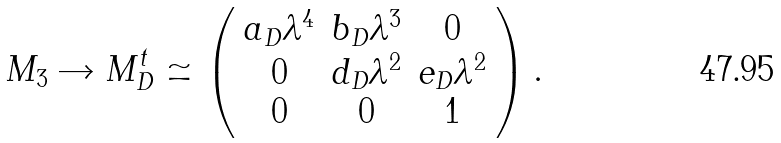Convert formula to latex. <formula><loc_0><loc_0><loc_500><loc_500>M _ { 3 } \rightarrow M _ { D } ^ { t } \simeq \left ( \begin{array} { c c c } a _ { D } \lambda ^ { 4 } & b _ { D } \lambda ^ { 3 } & 0 \\ 0 & d _ { D } \lambda ^ { 2 } & e _ { D } \lambda ^ { 2 } \\ 0 & 0 & 1 \\ \end{array} \right ) .</formula> 